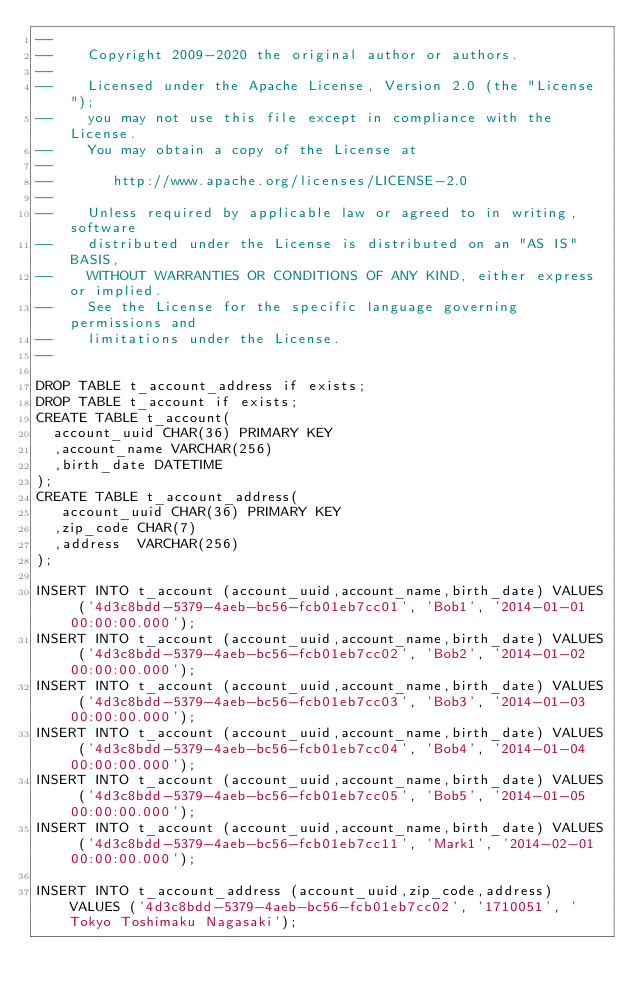<code> <loc_0><loc_0><loc_500><loc_500><_SQL_>--
--    Copyright 2009-2020 the original author or authors.
--
--    Licensed under the Apache License, Version 2.0 (the "License");
--    you may not use this file except in compliance with the License.
--    You may obtain a copy of the License at
--
--       http://www.apache.org/licenses/LICENSE-2.0
--
--    Unless required by applicable law or agreed to in writing, software
--    distributed under the License is distributed on an "AS IS" BASIS,
--    WITHOUT WARRANTIES OR CONDITIONS OF ANY KIND, either express or implied.
--    See the License for the specific language governing permissions and
--    limitations under the License.
--

DROP TABLE t_account_address if exists;
DROP TABLE t_account if exists;
CREATE TABLE t_account(
  account_uuid CHAR(36) PRIMARY KEY
  ,account_name VARCHAR(256)
  ,birth_date DATETIME
);
CREATE TABLE t_account_address(
   account_uuid CHAR(36) PRIMARY KEY
  ,zip_code CHAR(7)
  ,address  VARCHAR(256)
);

INSERT INTO t_account (account_uuid,account_name,birth_date) VALUES ('4d3c8bdd-5379-4aeb-bc56-fcb01eb7cc01', 'Bob1', '2014-01-01 00:00:00.000');
INSERT INTO t_account (account_uuid,account_name,birth_date) VALUES ('4d3c8bdd-5379-4aeb-bc56-fcb01eb7cc02', 'Bob2', '2014-01-02 00:00:00.000');
INSERT INTO t_account (account_uuid,account_name,birth_date) VALUES ('4d3c8bdd-5379-4aeb-bc56-fcb01eb7cc03', 'Bob3', '2014-01-03 00:00:00.000');
INSERT INTO t_account (account_uuid,account_name,birth_date) VALUES ('4d3c8bdd-5379-4aeb-bc56-fcb01eb7cc04', 'Bob4', '2014-01-04 00:00:00.000');
INSERT INTO t_account (account_uuid,account_name,birth_date) VALUES ('4d3c8bdd-5379-4aeb-bc56-fcb01eb7cc05', 'Bob5', '2014-01-05 00:00:00.000');
INSERT INTO t_account (account_uuid,account_name,birth_date) VALUES ('4d3c8bdd-5379-4aeb-bc56-fcb01eb7cc11', 'Mark1', '2014-02-01 00:00:00.000');

INSERT INTO t_account_address (account_uuid,zip_code,address) VALUES ('4d3c8bdd-5379-4aeb-bc56-fcb01eb7cc02', '1710051', 'Tokyo Toshimaku Nagasaki');
</code> 